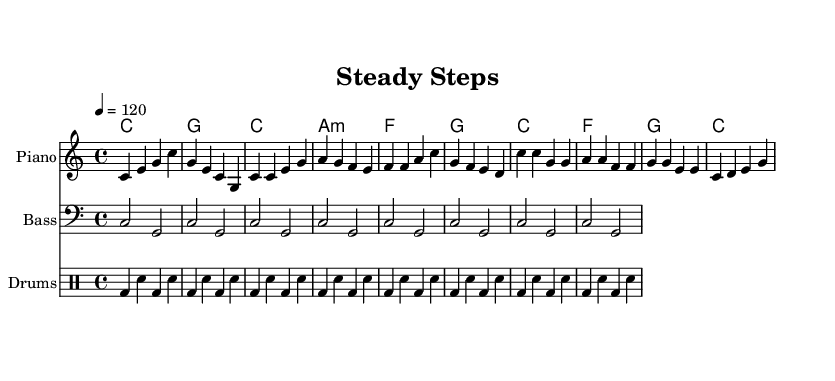what is the key signature of this music? The key signature is indicated at the beginning of the sheet music. It is C major, which has no sharps or flats.
Answer: C major what is the time signature of this piece? The time signature is found in the initial part of the music sheet, indicating how many beats are in a measure. It shows 4/4, meaning there are four beats per measure.
Answer: 4/4 what is the tempo marking for this piece? The tempo is specified in beats per minute (BPM) above the staff. In this case, the marking indicates a tempo of 120 beats per minute, suggesting a moderately fast pace.
Answer: 120 how many measures are in the chorus section? The chorus section can be identified by the notation pattern, specifically looking at the relevant segment of the music where the chorus occurs. It consists of four measures.
Answer: 4 what type of dance is this music suitable for? The music is characterized by a steady and upbeat rhythm, making it particularly suitable for rhythmic dance songs, which are often used in gait training exercises for rehabilitation.
Answer: Dance what is the simplified bass pattern used in the music? The sheet music shows that the bass has a repeating pattern of two notes: C and G, notated in a rhythmic way that emphasizes these notes. The simplified bass pattern alternates between C and G through the measures.
Answer: C, G how many different instruments are indicated in this arrangement? The sheet music shows multiple staffs, each representing a different instrument. There are three: Piano, Bass, and Drums, indicating a trio setup in the arrangement.
Answer: 3 